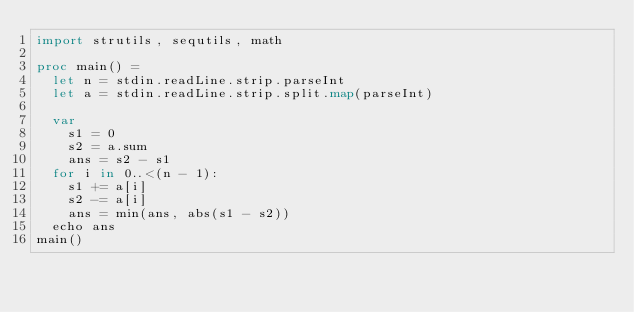Convert code to text. <code><loc_0><loc_0><loc_500><loc_500><_Nim_>import strutils, sequtils, math

proc main() =
  let n = stdin.readLine.strip.parseInt
  let a = stdin.readLine.strip.split.map(parseInt)

  var
    s1 = 0
    s2 = a.sum
    ans = s2 - s1
  for i in 0..<(n - 1):
    s1 += a[i]
    s2 -= a[i]
    ans = min(ans, abs(s1 - s2))
  echo ans
main()
</code> 